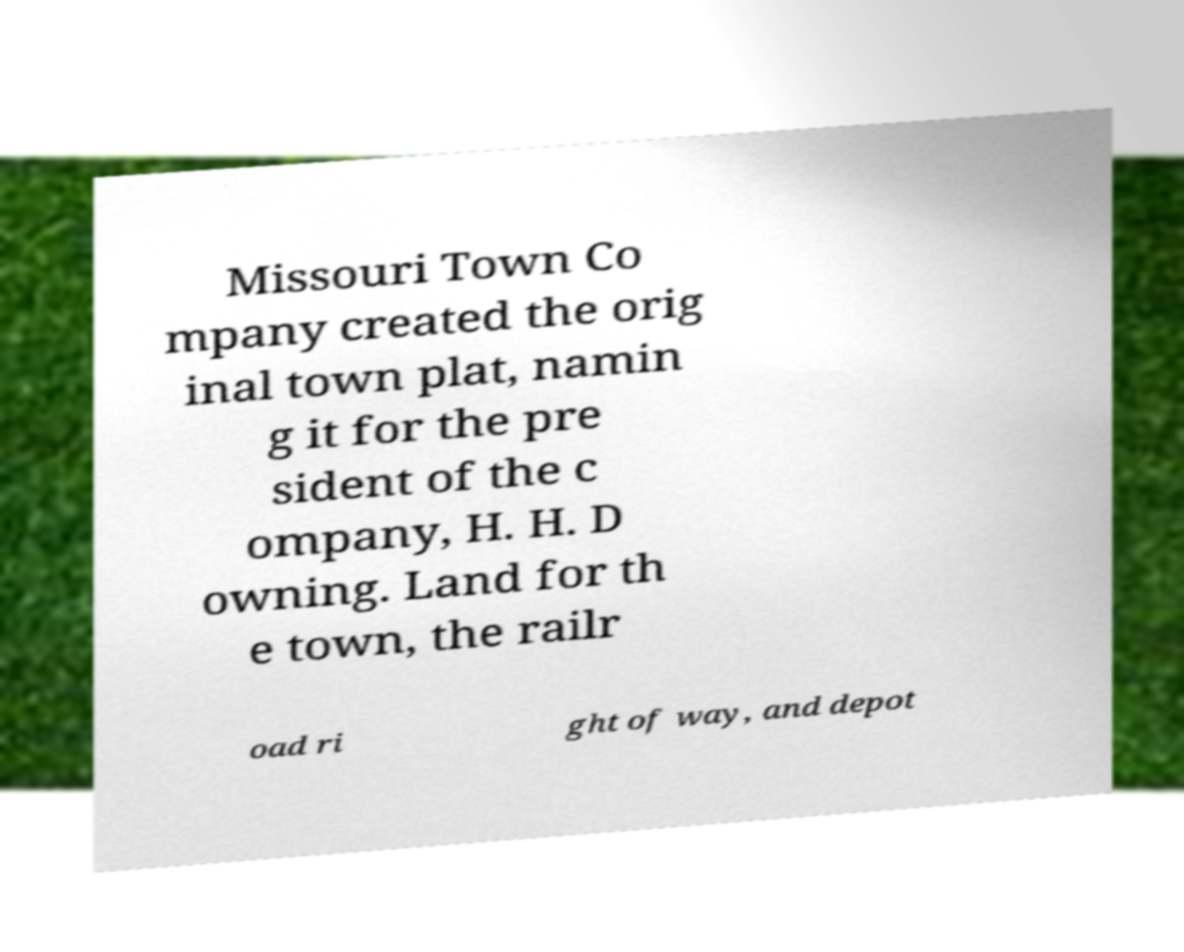Please read and relay the text visible in this image. What does it say? Missouri Town Co mpany created the orig inal town plat, namin g it for the pre sident of the c ompany, H. H. D owning. Land for th e town, the railr oad ri ght of way, and depot 